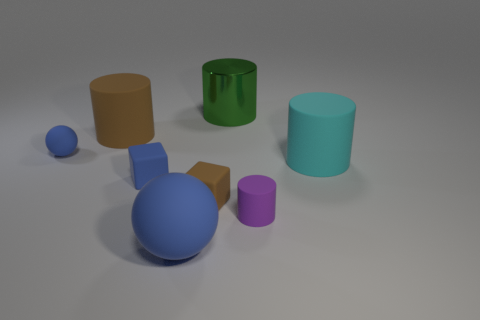What shape is the big object that is the same color as the small sphere?
Provide a short and direct response. Sphere. Does the large shiny object have the same color as the small cylinder?
Make the answer very short. No. What size is the purple cylinder?
Give a very brief answer. Small. How many small cubes are the same color as the small ball?
Offer a terse response. 1. Are there any big things that are right of the rubber thing that is in front of the small matte thing that is to the right of the green metallic object?
Provide a succinct answer. Yes. There is a purple rubber object that is the same size as the brown rubber block; what shape is it?
Provide a short and direct response. Cylinder. How many small objects are gray things or green things?
Ensure brevity in your answer.  0. What color is the small sphere that is made of the same material as the blue block?
Offer a very short reply. Blue. There is a brown thing behind the tiny blue sphere; is it the same shape as the large green metal thing left of the cyan rubber cylinder?
Give a very brief answer. Yes. What number of metal objects are large blue spheres or tiny blocks?
Your answer should be compact. 0. 